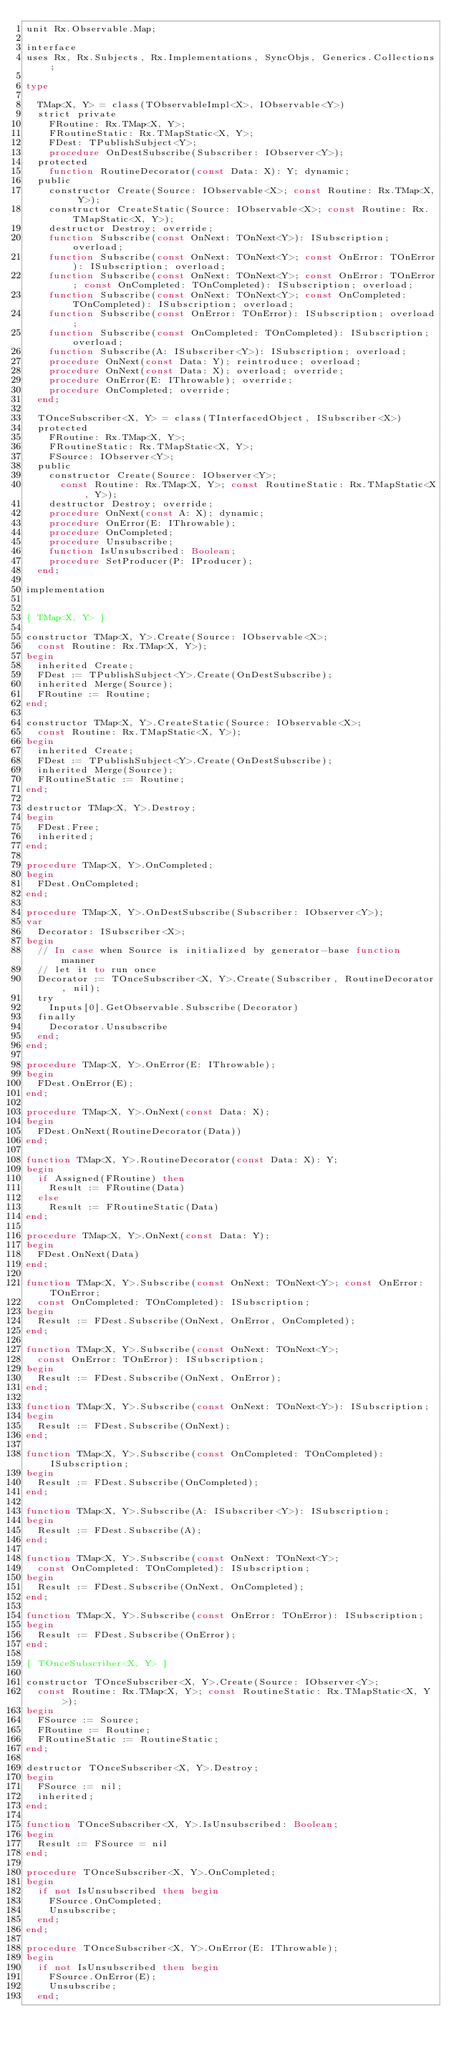Convert code to text. <code><loc_0><loc_0><loc_500><loc_500><_Pascal_>unit Rx.Observable.Map;

interface
uses Rx, Rx.Subjects, Rx.Implementations, SyncObjs, Generics.Collections;

type

  TMap<X, Y> = class(TObservableImpl<X>, IObservable<Y>)
  strict private
    FRoutine: Rx.TMap<X, Y>;
    FRoutineStatic: Rx.TMapStatic<X, Y>;
    FDest: TPublishSubject<Y>;
    procedure OnDestSubscribe(Subscriber: IObserver<Y>);
  protected
    function RoutineDecorator(const Data: X): Y; dynamic;
  public
    constructor Create(Source: IObservable<X>; const Routine: Rx.TMap<X, Y>);
    constructor CreateStatic(Source: IObservable<X>; const Routine: Rx.TMapStatic<X, Y>);
    destructor Destroy; override;
    function Subscribe(const OnNext: TOnNext<Y>): ISubscription; overload;
    function Subscribe(const OnNext: TOnNext<Y>; const OnError: TOnError): ISubscription; overload;
    function Subscribe(const OnNext: TOnNext<Y>; const OnError: TOnError; const OnCompleted: TOnCompleted): ISubscription; overload;
    function Subscribe(const OnNext: TOnNext<Y>; const OnCompleted: TOnCompleted): ISubscription; overload;
    function Subscribe(const OnError: TOnError): ISubscription; overload;
    function Subscribe(const OnCompleted: TOnCompleted): ISubscription; overload;
    function Subscribe(A: ISubscriber<Y>): ISubscription; overload;
    procedure OnNext(const Data: Y); reintroduce; overload;
    procedure OnNext(const Data: X); overload; override;
    procedure OnError(E: IThrowable); override;
    procedure OnCompleted; override;
  end;

  TOnceSubscriber<X, Y> = class(TInterfacedObject, ISubscriber<X>)
  protected
    FRoutine: Rx.TMap<X, Y>;
    FRoutineStatic: Rx.TMapStatic<X, Y>;
    FSource: IObserver<Y>;
  public
    constructor Create(Source: IObserver<Y>;
      const Routine: Rx.TMap<X, Y>; const RoutineStatic: Rx.TMapStatic<X, Y>);
    destructor Destroy; override;
    procedure OnNext(const A: X); dynamic;
    procedure OnError(E: IThrowable);
    procedure OnCompleted;
    procedure Unsubscribe;
    function IsUnsubscribed: Boolean;
    procedure SetProducer(P: IProducer);
  end;

implementation


{ TMap<X, Y> }

constructor TMap<X, Y>.Create(Source: IObservable<X>;
  const Routine: Rx.TMap<X, Y>);
begin
  inherited Create;
  FDest := TPublishSubject<Y>.Create(OnDestSubscribe);
  inherited Merge(Source);
  FRoutine := Routine;
end;

constructor TMap<X, Y>.CreateStatic(Source: IObservable<X>;
  const Routine: Rx.TMapStatic<X, Y>);
begin
  inherited Create;
  FDest := TPublishSubject<Y>.Create(OnDestSubscribe);
  inherited Merge(Source);
  FRoutineStatic := Routine;
end;

destructor TMap<X, Y>.Destroy;
begin
  FDest.Free;
  inherited;
end;

procedure TMap<X, Y>.OnCompleted;
begin
  FDest.OnCompleted;
end;

procedure TMap<X, Y>.OnDestSubscribe(Subscriber: IObserver<Y>);
var
  Decorator: ISubscriber<X>;
begin
  // In case when Source is initialized by generator-base function manner
  // let it to run once
  Decorator := TOnceSubscriber<X, Y>.Create(Subscriber, RoutineDecorator, nil);
  try
    Inputs[0].GetObservable.Subscribe(Decorator)
  finally
    Decorator.Unsubscribe
  end;
end;

procedure TMap<X, Y>.OnError(E: IThrowable);
begin
  FDest.OnError(E);
end;

procedure TMap<X, Y>.OnNext(const Data: X);
begin
  FDest.OnNext(RoutineDecorator(Data))
end;

function TMap<X, Y>.RoutineDecorator(const Data: X): Y;
begin
  if Assigned(FRoutine) then
    Result := FRoutine(Data)
  else
    Result := FRoutineStatic(Data)
end;

procedure TMap<X, Y>.OnNext(const Data: Y);
begin
  FDest.OnNext(Data)
end;

function TMap<X, Y>.Subscribe(const OnNext: TOnNext<Y>; const OnError: TOnError;
  const OnCompleted: TOnCompleted): ISubscription;
begin
  Result := FDest.Subscribe(OnNext, OnError, OnCompleted);
end;

function TMap<X, Y>.Subscribe(const OnNext: TOnNext<Y>;
  const OnError: TOnError): ISubscription;
begin
  Result := FDest.Subscribe(OnNext, OnError);
end;

function TMap<X, Y>.Subscribe(const OnNext: TOnNext<Y>): ISubscription;
begin
  Result := FDest.Subscribe(OnNext);
end;

function TMap<X, Y>.Subscribe(const OnCompleted: TOnCompleted): ISubscription;
begin
  Result := FDest.Subscribe(OnCompleted);
end;

function TMap<X, Y>.Subscribe(A: ISubscriber<Y>): ISubscription;
begin
  Result := FDest.Subscribe(A);
end;

function TMap<X, Y>.Subscribe(const OnNext: TOnNext<Y>;
  const OnCompleted: TOnCompleted): ISubscription;
begin
  Result := FDest.Subscribe(OnNext, OnCompleted);
end;

function TMap<X, Y>.Subscribe(const OnError: TOnError): ISubscription;
begin
  Result := FDest.Subscribe(OnError);
end;

{ TOnceSubscriber<X, Y> }

constructor TOnceSubscriber<X, Y>.Create(Source: IObserver<Y>;
  const Routine: Rx.TMap<X, Y>; const RoutineStatic: Rx.TMapStatic<X, Y>);
begin
  FSource := Source;
  FRoutine := Routine;
  FRoutineStatic := RoutineStatic;
end;

destructor TOnceSubscriber<X, Y>.Destroy;
begin
  FSource := nil;
  inherited;
end;

function TOnceSubscriber<X, Y>.IsUnsubscribed: Boolean;
begin
  Result := FSource = nil
end;

procedure TOnceSubscriber<X, Y>.OnCompleted;
begin
  if not IsUnsubscribed then begin
    FSource.OnCompleted;
    Unsubscribe;
  end;
end;

procedure TOnceSubscriber<X, Y>.OnError(E: IThrowable);
begin
  if not IsUnsubscribed then begin
    FSource.OnError(E);
    Unsubscribe;
  end;</code> 